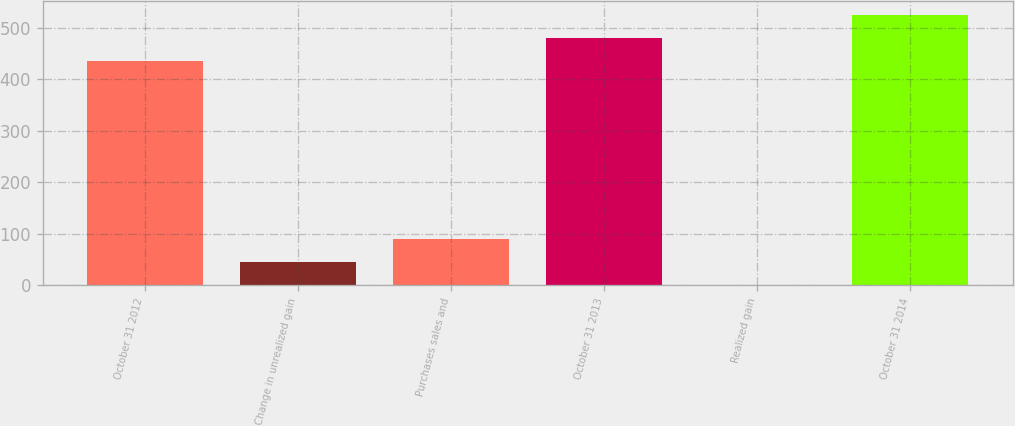Convert chart. <chart><loc_0><loc_0><loc_500><loc_500><bar_chart><fcel>October 31 2012<fcel>Change in unrealized gain<fcel>Purchases sales and<fcel>October 31 2013<fcel>Realized gain<fcel>October 31 2014<nl><fcel>436<fcel>45.5<fcel>90<fcel>480.5<fcel>1<fcel>525<nl></chart> 